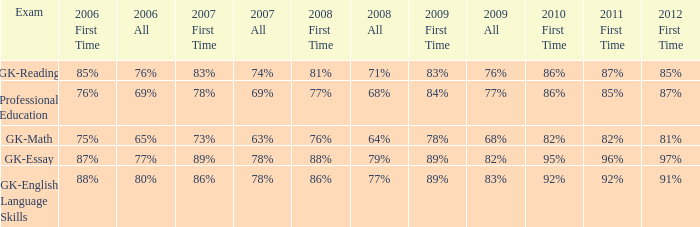What is the percentage for all 2008 when all in 2007 is 69%? 68%. 